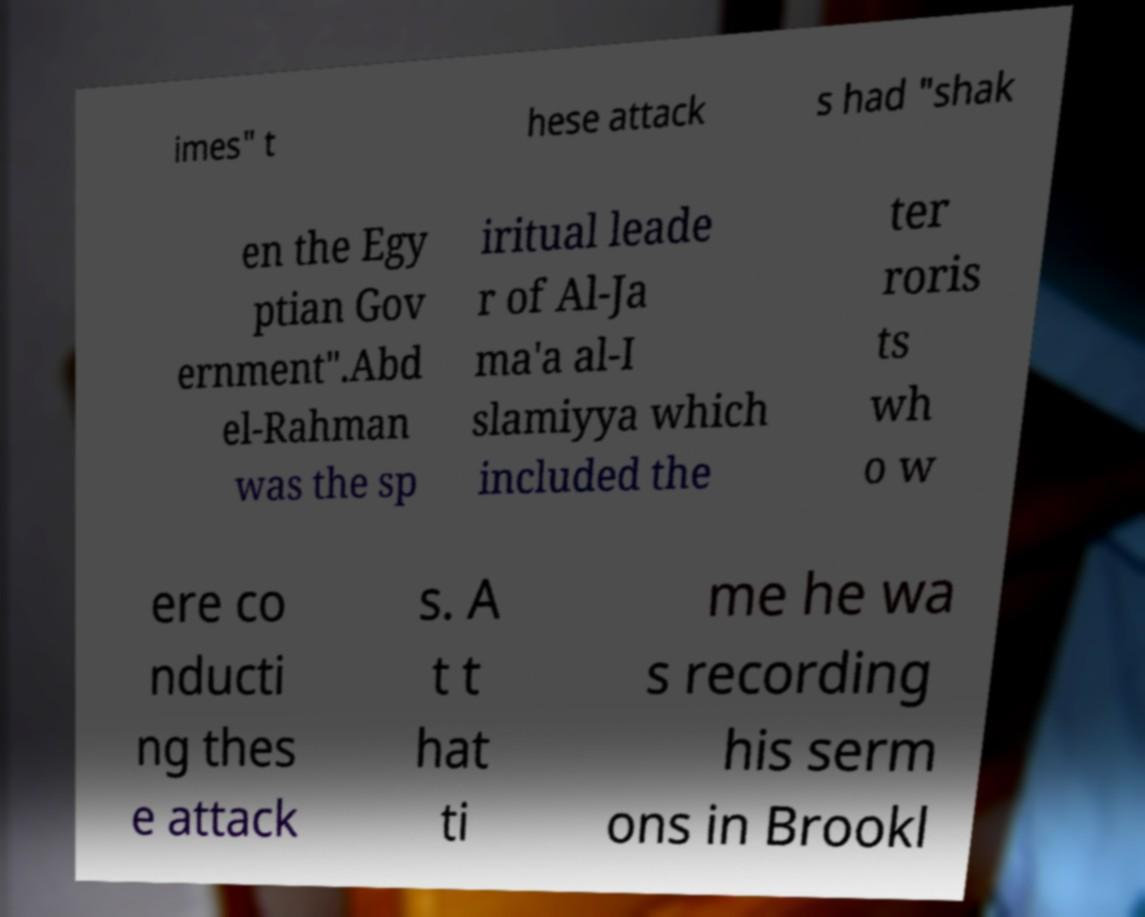Please identify and transcribe the text found in this image. imes" t hese attack s had "shak en the Egy ptian Gov ernment".Abd el-Rahman was the sp iritual leade r of Al-Ja ma'a al-I slamiyya which included the ter roris ts wh o w ere co nducti ng thes e attack s. A t t hat ti me he wa s recording his serm ons in Brookl 